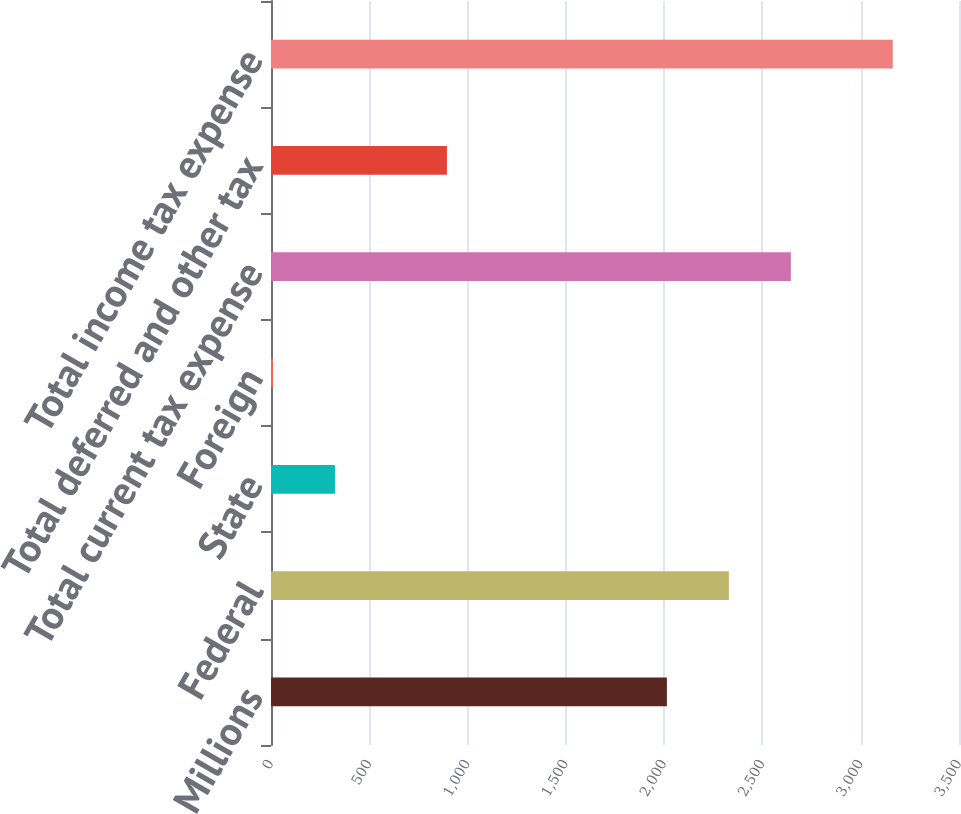Convert chart. <chart><loc_0><loc_0><loc_500><loc_500><bar_chart><fcel>Millions<fcel>Federal<fcel>State<fcel>Foreign<fcel>Total current tax expense<fcel>Total deferred and other tax<fcel>Total income tax expense<nl><fcel>2014<fcel>2329.3<fcel>325.3<fcel>10<fcel>2644.6<fcel>895<fcel>3163<nl></chart> 